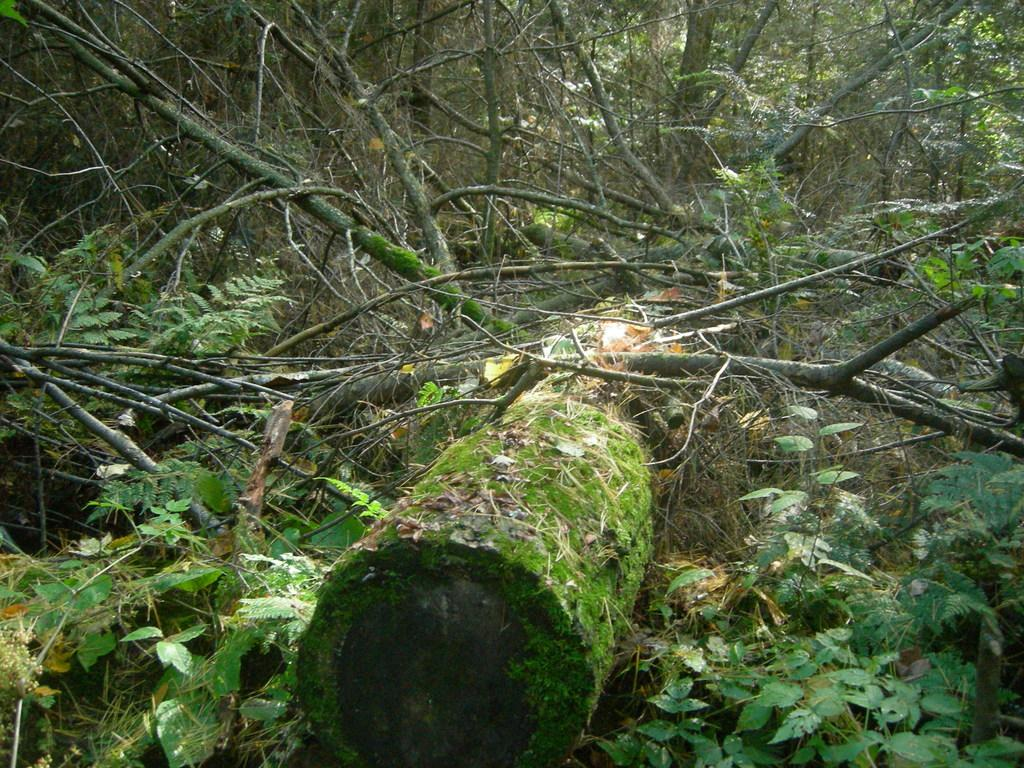What type of vegetation can be seen in the image? There are trees and plants in the image. Can you describe the condition of one of the trees in the image? There is a broken tree on the ground in the image. How do the plants in the image sort themselves by color? The plants in the image do not sort themselves by color; there is no indication of color sorting in the image. 